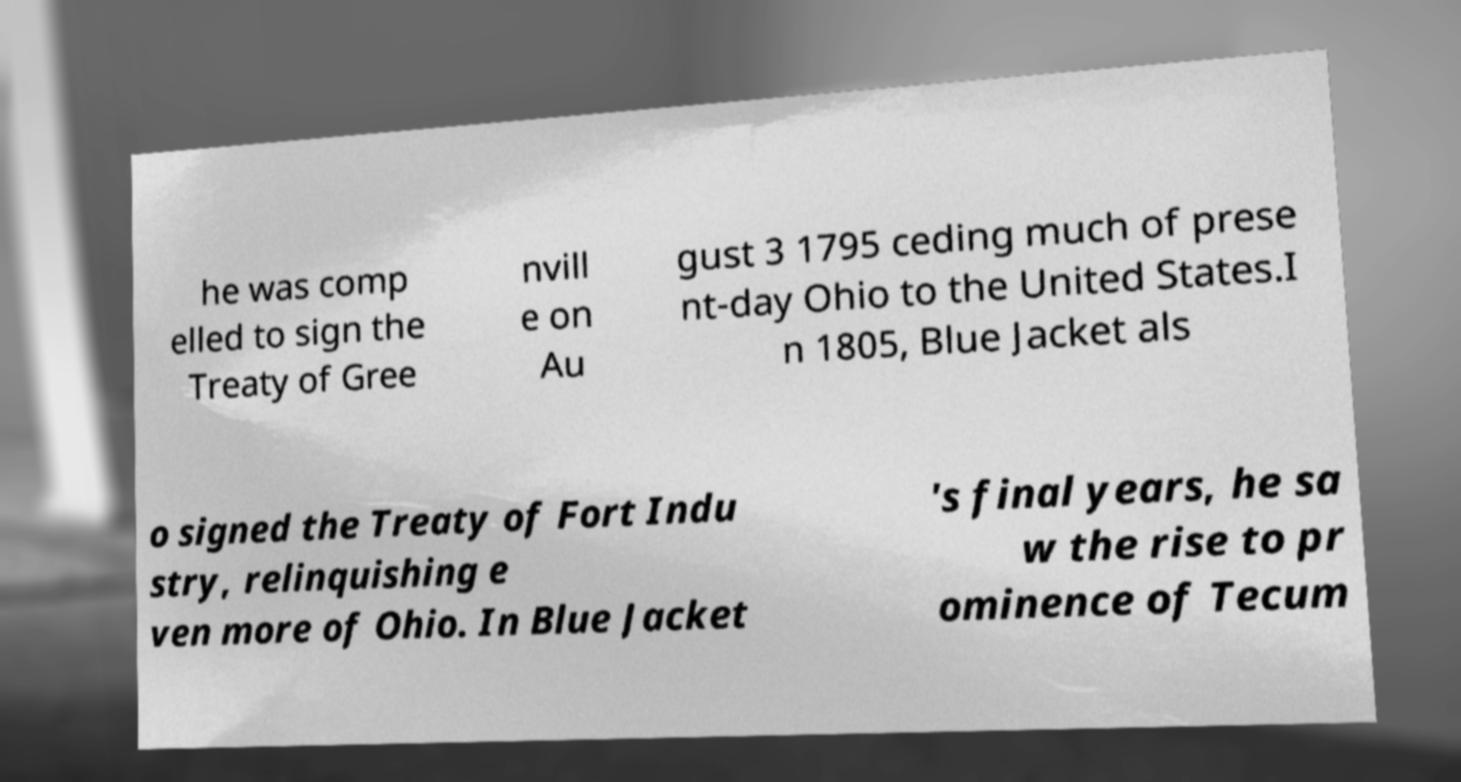Please identify and transcribe the text found in this image. he was comp elled to sign the Treaty of Gree nvill e on Au gust 3 1795 ceding much of prese nt-day Ohio to the United States.I n 1805, Blue Jacket als o signed the Treaty of Fort Indu stry, relinquishing e ven more of Ohio. In Blue Jacket 's final years, he sa w the rise to pr ominence of Tecum 